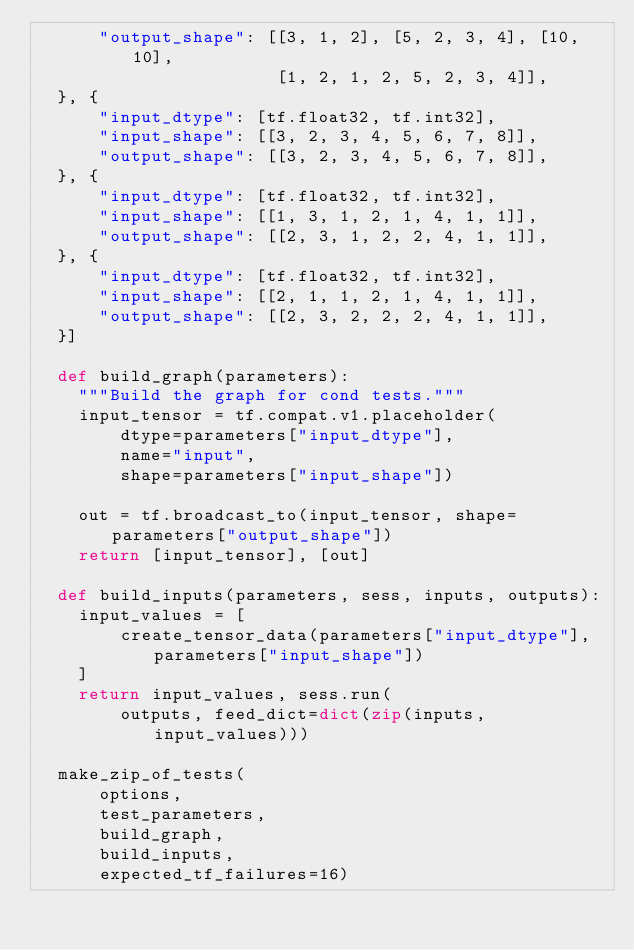<code> <loc_0><loc_0><loc_500><loc_500><_Python_>      "output_shape": [[3, 1, 2], [5, 2, 3, 4], [10, 10],
                       [1, 2, 1, 2, 5, 2, 3, 4]],
  }, {
      "input_dtype": [tf.float32, tf.int32],
      "input_shape": [[3, 2, 3, 4, 5, 6, 7, 8]],
      "output_shape": [[3, 2, 3, 4, 5, 6, 7, 8]],
  }, {
      "input_dtype": [tf.float32, tf.int32],
      "input_shape": [[1, 3, 1, 2, 1, 4, 1, 1]],
      "output_shape": [[2, 3, 1, 2, 2, 4, 1, 1]],
  }, {
      "input_dtype": [tf.float32, tf.int32],
      "input_shape": [[2, 1, 1, 2, 1, 4, 1, 1]],
      "output_shape": [[2, 3, 2, 2, 2, 4, 1, 1]],
  }]

  def build_graph(parameters):
    """Build the graph for cond tests."""
    input_tensor = tf.compat.v1.placeholder(
        dtype=parameters["input_dtype"],
        name="input",
        shape=parameters["input_shape"])

    out = tf.broadcast_to(input_tensor, shape=parameters["output_shape"])
    return [input_tensor], [out]

  def build_inputs(parameters, sess, inputs, outputs):
    input_values = [
        create_tensor_data(parameters["input_dtype"], parameters["input_shape"])
    ]
    return input_values, sess.run(
        outputs, feed_dict=dict(zip(inputs, input_values)))

  make_zip_of_tests(
      options,
      test_parameters,
      build_graph,
      build_inputs,
      expected_tf_failures=16)
</code> 